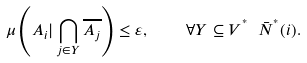<formula> <loc_0><loc_0><loc_500><loc_500>\mu \left ( A _ { i } | \bigcap _ { j \in Y } \overline { A _ { j } } \right ) \leq \varepsilon , \quad \forall Y \subseteq V ^ { ^ { * } } \ \bar { N } ^ { ^ { * } } ( i ) .</formula> 